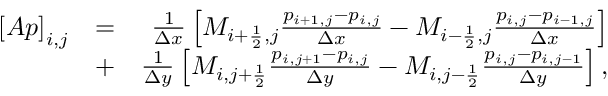Convert formula to latex. <formula><loc_0><loc_0><loc_500><loc_500>\begin{array} { r l r } { \left [ A p \right ] _ { i , j } } & { = } & { \frac { 1 } { \Delta x } \left [ M _ { i + \frac { 1 } { 2 } , j } \frac { p _ { i + 1 , j } - p _ { i , j } } { \Delta x } - M _ { i - \frac { 1 } { 2 } , j } \frac { p _ { i , j } - p _ { i - 1 , j } } { \Delta x } \right ] } \\ & { + } & { \frac { 1 } { \Delta y } \left [ M _ { i , j + \frac { 1 } { 2 } } \frac { p _ { i , j + 1 } - p _ { i , j } } { \Delta y } - M _ { i , j - \frac { 1 } { 2 } } \frac { p _ { i , j } - p _ { i , j - 1 } } { \Delta y } \right ] , } \end{array}</formula> 